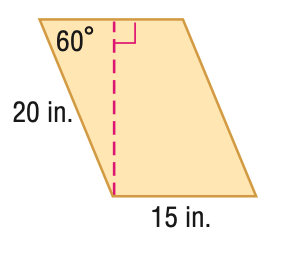Answer the mathemtical geometry problem and directly provide the correct option letter.
Question: Find the area of the parallelogram. Round to the nearest tenth if necessary.
Choices: A: 86.6 B: 129.9 C: 150.0 D: 259.8 D 